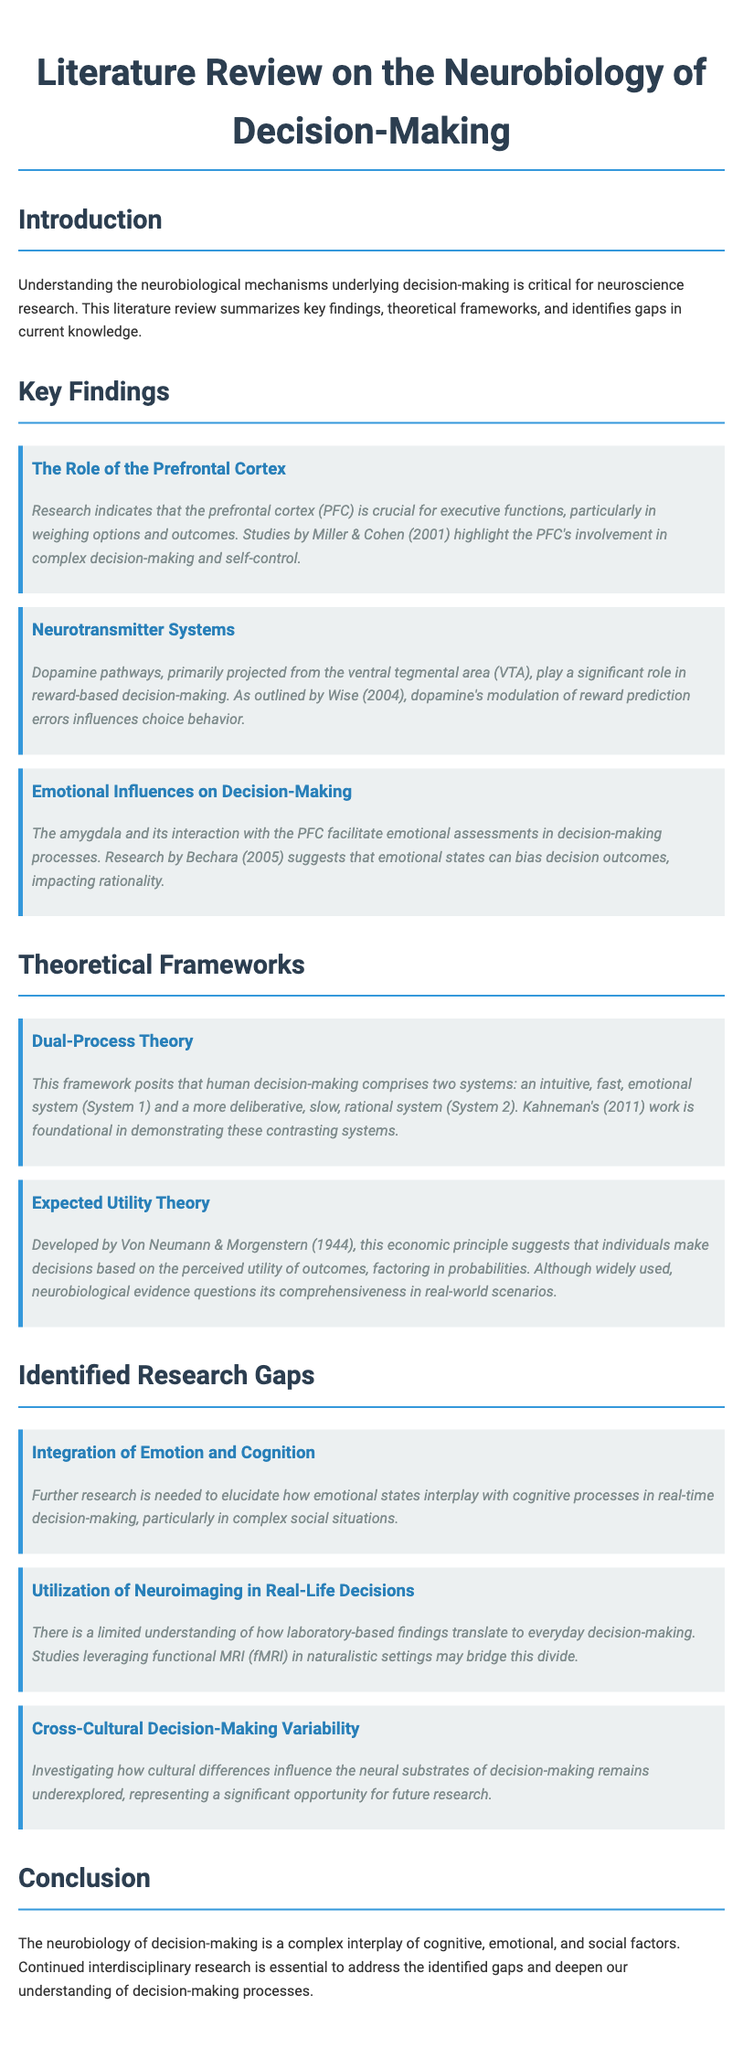What is the main focus of this literature review? The literature review focuses on understanding the neurobiological mechanisms underlying decision-making.
Answer: neurobiological mechanisms Who conducted studies highlighting the PFC's role in decision-making? The studies discussing the prefrontal cortex's involvement in complex decision-making were conducted by Miller & Cohen.
Answer: Miller & Cohen What system does the Dual-Process Theory posit as intuitive and fast? Dual-Process Theory defines the intuitive and fast system as System 1.
Answer: System 1 What neurotransmitter pathways are mentioned in relation to reward-based decision-making? The document mentions dopamine pathways, primarily projected from the ventral tegmental area.
Answer: dopamine pathways What is one identified research gap in decision-making literature? One identified research gap is the integration of emotion and cognition in real-time decision-making.
Answer: integration of emotion and cognition What year was the Expected Utility Theory developed? Expected Utility Theory was developed in 1944.
Answer: 1944 Which emotional structure interacts with the PFC according to the findings? The emotional structure that interacts with the PFC is the amygdala.
Answer: amygdala What type of studies are suggested to bridge the divide in laboratory findings to everyday decision-making? The document suggests studies leveraging functional MRI in naturalistic settings.
Answer: functional MRI Which cultural aspect remains underexplored in decision-making research? The document states that cross-cultural decision-making variability remains underexplored.
Answer: cross-cultural decision-making variability 